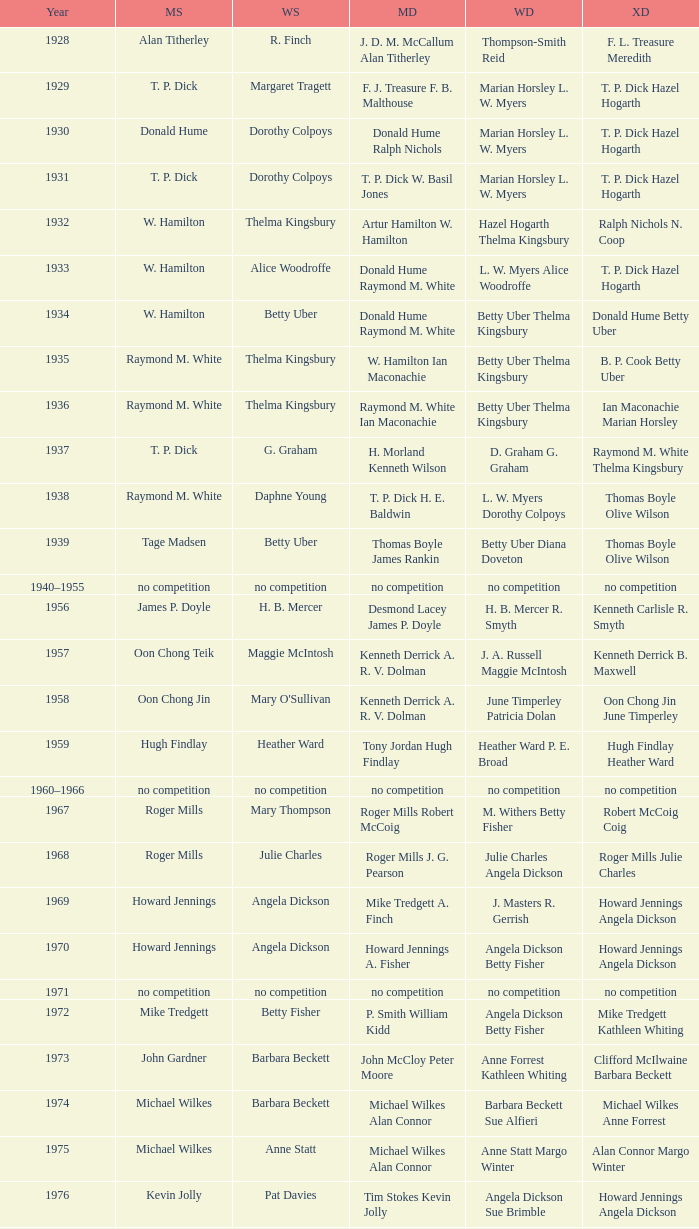Who won the Women's doubles in the year that Jesper Knudsen Nettie Nielsen won the Mixed doubles? Karen Beckman Sara Halsall. 